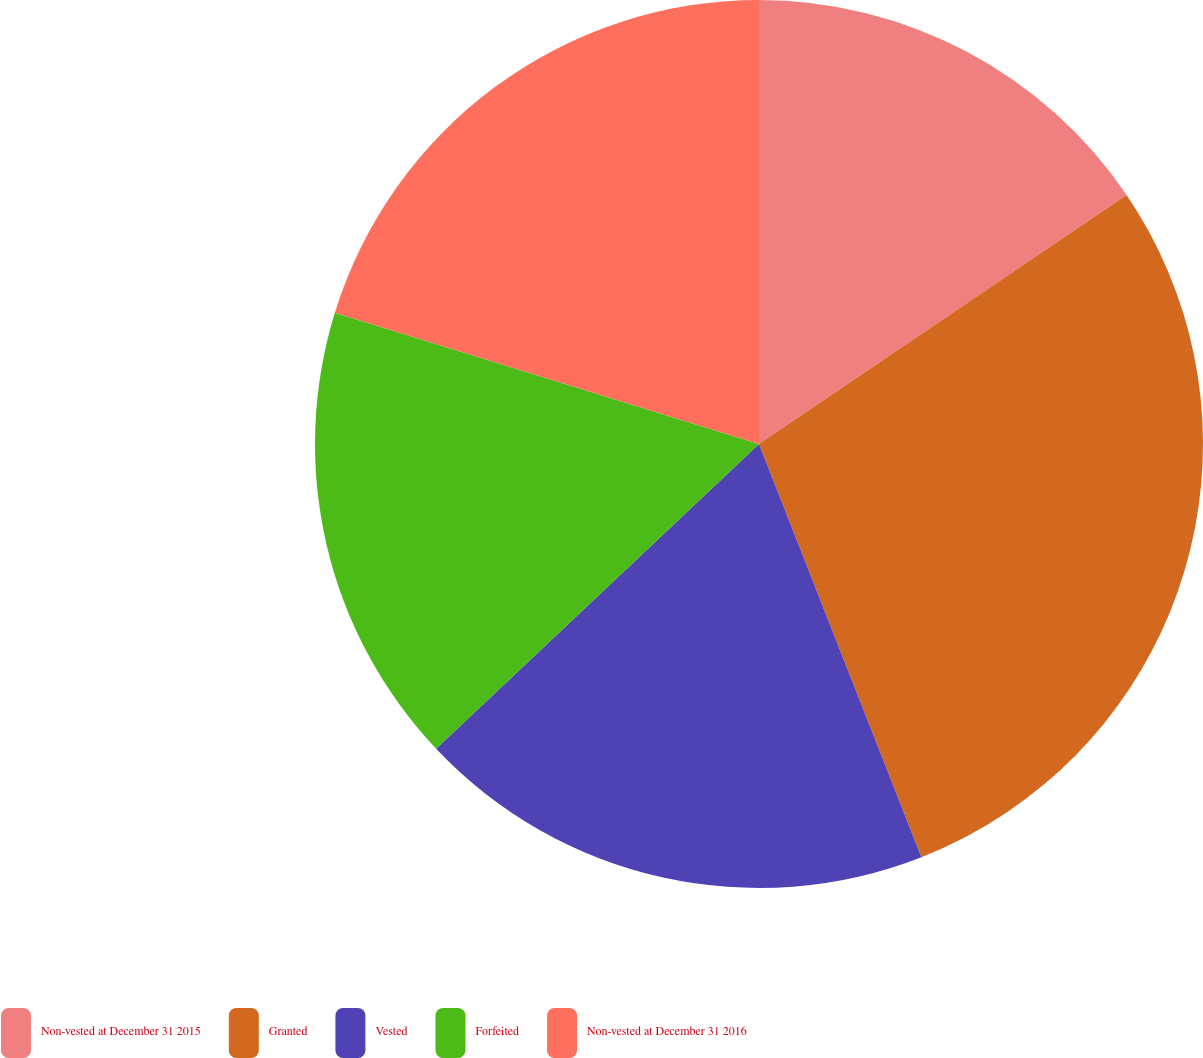Convert chart to OTSL. <chart><loc_0><loc_0><loc_500><loc_500><pie_chart><fcel>Non-vested at December 31 2015<fcel>Granted<fcel>Vested<fcel>Forfeited<fcel>Non-vested at December 31 2016<nl><fcel>15.52%<fcel>28.52%<fcel>18.92%<fcel>16.82%<fcel>20.22%<nl></chart> 